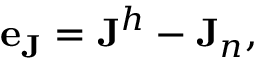Convert formula to latex. <formula><loc_0><loc_0><loc_500><loc_500>\begin{array} { r } { e _ { J } = J ^ { h } - J _ { n } , } \end{array}</formula> 